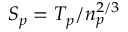<formula> <loc_0><loc_0><loc_500><loc_500>S _ { p } = T _ { p } / n _ { p } ^ { 2 / 3 }</formula> 